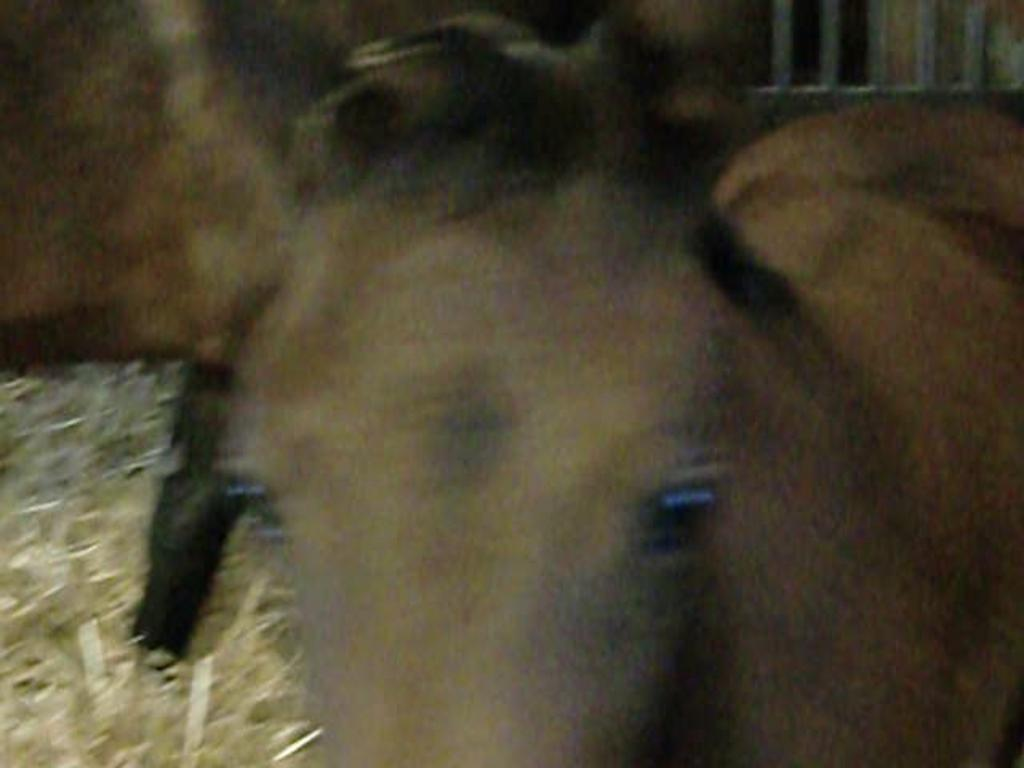What type of living creature is present in the image? There is an animal in the image. Can you describe the background of the image? The background of the image is blurred. What type of mailbox can be seen in the image? There is no mailbox present in the image. How does the animal's growth appear in the image? The animal's growth cannot be determined from the image, as it only shows the animal and a blurred background. 